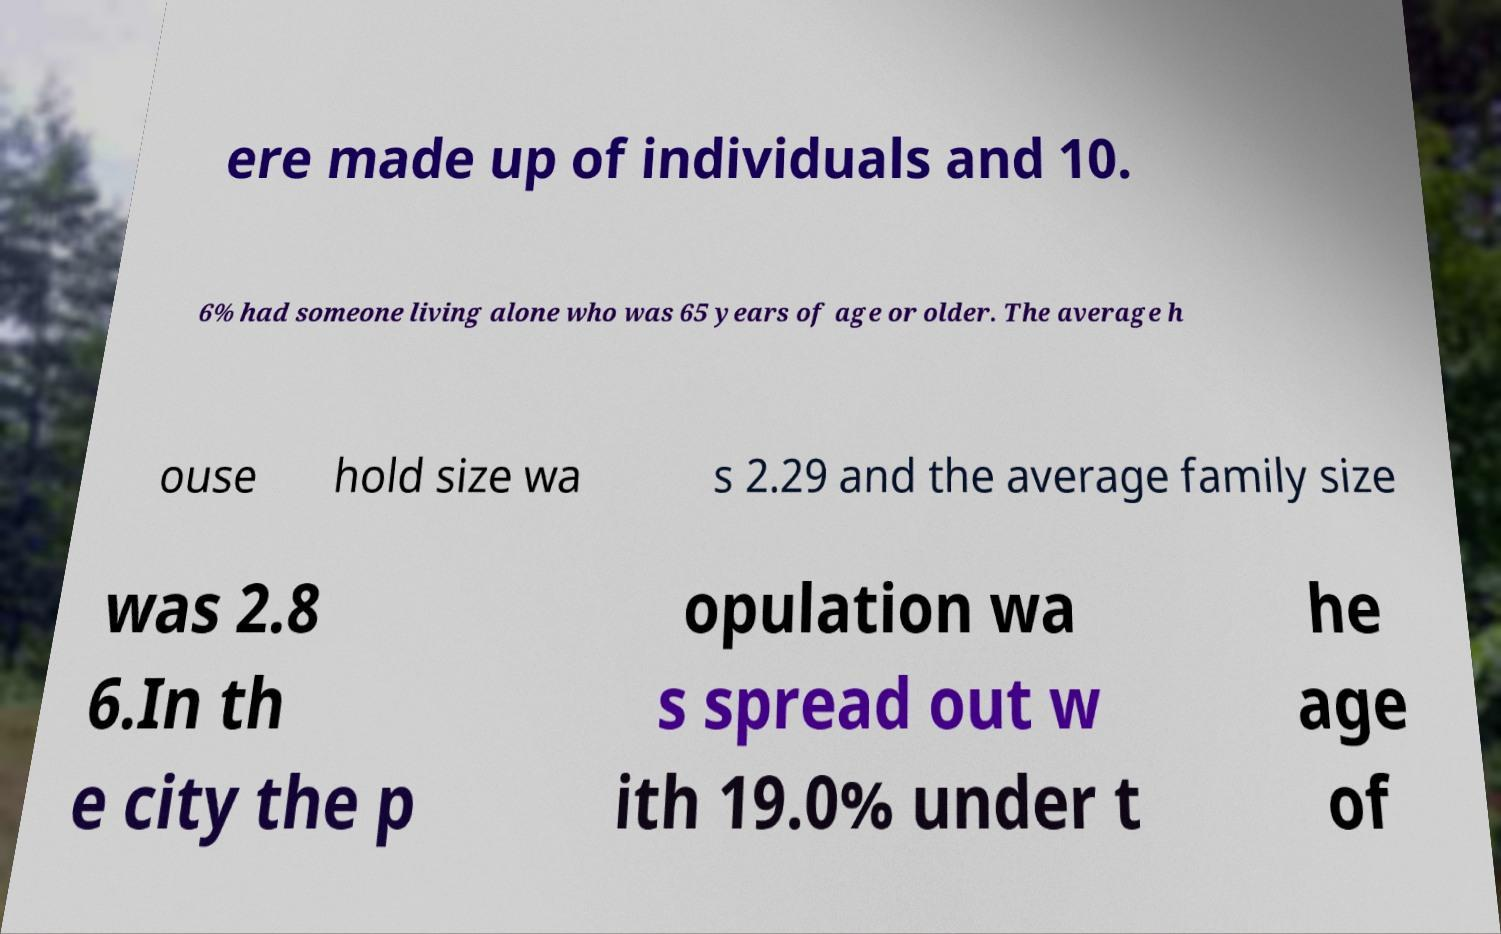Please read and relay the text visible in this image. What does it say? ere made up of individuals and 10. 6% had someone living alone who was 65 years of age or older. The average h ouse hold size wa s 2.29 and the average family size was 2.8 6.In th e city the p opulation wa s spread out w ith 19.0% under t he age of 